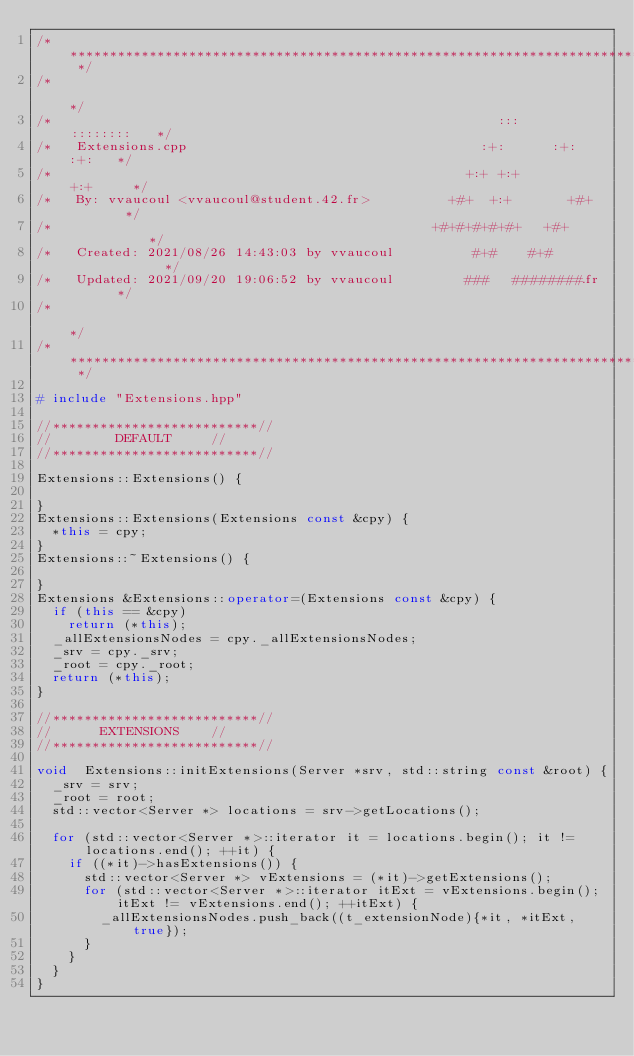Convert code to text. <code><loc_0><loc_0><loc_500><loc_500><_C++_>/* ************************************************************************** */
/*                                                                            */
/*                                                        :::      ::::::::   */
/*   Extensions.cpp                                     :+:      :+:    :+:   */
/*                                                    +:+ +:+         +:+     */
/*   By: vvaucoul <vvaucoul@student.42.fr>          +#+  +:+       +#+        */
/*                                                +#+#+#+#+#+   +#+           */
/*   Created: 2021/08/26 14:43:03 by vvaucoul          #+#    #+#             */
/*   Updated: 2021/09/20 19:06:52 by vvaucoul         ###   ########.fr       */
/*                                                                            */
/* ************************************************************************** */

# include "Extensions.hpp"

//**************************//
//		    DEFAULT			//
//**************************//

Extensions::Extensions() {

}
Extensions::Extensions(Extensions const &cpy) {
	*this = cpy;
}
Extensions::~Extensions() {

}
Extensions &Extensions::operator=(Extensions const &cpy) {
	if (this == &cpy)
		return (*this);
	_allExtensionsNodes = cpy._allExtensionsNodes;
	_srv = cpy._srv;
	_root = cpy._root;
	return (*this);
}

//**************************//
//		  EXTENSIONS		//
//**************************//

void 	Extensions::initExtensions(Server *srv, std::string const &root) {
	_srv = srv;
	_root = root;
	std::vector<Server *> locations = srv->getLocations();

	for (std::vector<Server *>::iterator it = locations.begin(); it != locations.end(); ++it) {
		if ((*it)->hasExtensions()) {
			std::vector<Server *> vExtensions = (*it)->getExtensions();
			for (std::vector<Server *>::iterator itExt = vExtensions.begin(); itExt != vExtensions.end(); ++itExt) {
				_allExtensionsNodes.push_back((t_extensionNode){*it, *itExt, true});
			}
		}
	}
}
</code> 